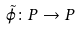Convert formula to latex. <formula><loc_0><loc_0><loc_500><loc_500>\tilde { \varphi } \colon P \rightarrow P</formula> 